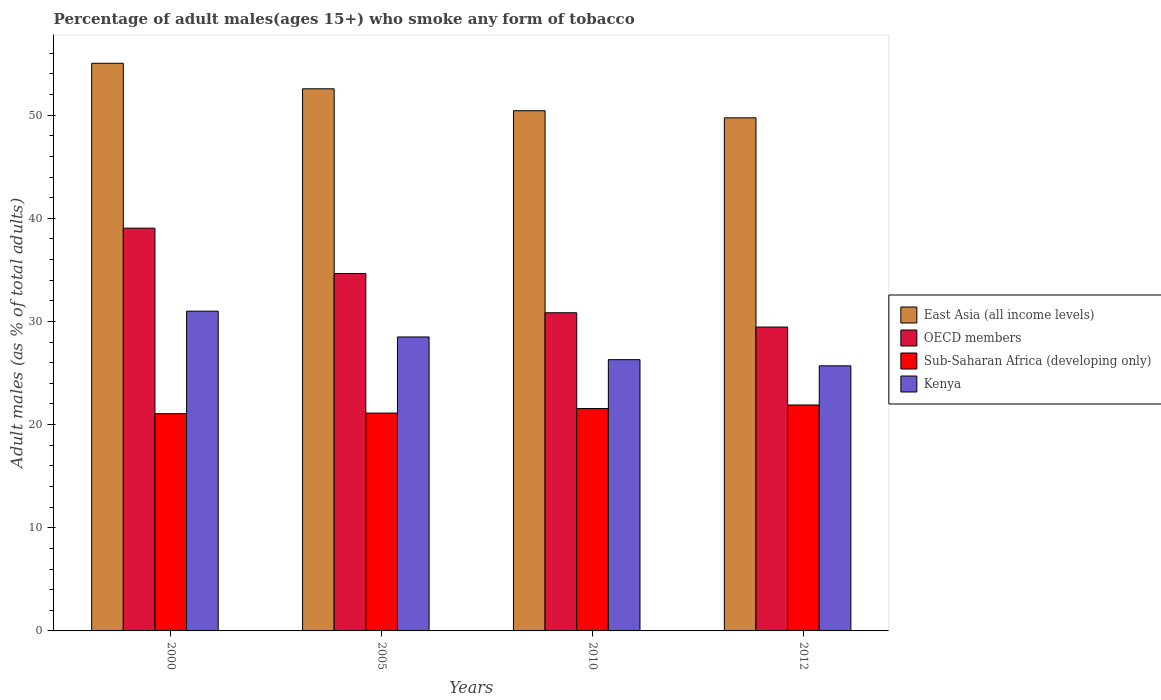How many different coloured bars are there?
Provide a succinct answer. 4. How many groups of bars are there?
Your answer should be very brief. 4. Are the number of bars per tick equal to the number of legend labels?
Your answer should be compact. Yes. How many bars are there on the 2nd tick from the left?
Keep it short and to the point. 4. What is the label of the 2nd group of bars from the left?
Make the answer very short. 2005. In how many cases, is the number of bars for a given year not equal to the number of legend labels?
Offer a terse response. 0. What is the percentage of adult males who smoke in Sub-Saharan Africa (developing only) in 2000?
Give a very brief answer. 21.06. Across all years, what is the maximum percentage of adult males who smoke in Kenya?
Provide a succinct answer. 31. Across all years, what is the minimum percentage of adult males who smoke in Kenya?
Your response must be concise. 25.7. What is the total percentage of adult males who smoke in East Asia (all income levels) in the graph?
Your answer should be compact. 207.77. What is the difference between the percentage of adult males who smoke in East Asia (all income levels) in 2005 and that in 2012?
Keep it short and to the point. 2.81. What is the difference between the percentage of adult males who smoke in Kenya in 2010 and the percentage of adult males who smoke in OECD members in 2012?
Provide a succinct answer. -3.16. What is the average percentage of adult males who smoke in Kenya per year?
Provide a succinct answer. 27.88. In the year 2012, what is the difference between the percentage of adult males who smoke in East Asia (all income levels) and percentage of adult males who smoke in Kenya?
Give a very brief answer. 24.04. In how many years, is the percentage of adult males who smoke in East Asia (all income levels) greater than 24 %?
Your response must be concise. 4. What is the ratio of the percentage of adult males who smoke in Sub-Saharan Africa (developing only) in 2005 to that in 2012?
Provide a succinct answer. 0.96. Is the percentage of adult males who smoke in Sub-Saharan Africa (developing only) in 2000 less than that in 2012?
Your answer should be very brief. Yes. Is the difference between the percentage of adult males who smoke in East Asia (all income levels) in 2010 and 2012 greater than the difference between the percentage of adult males who smoke in Kenya in 2010 and 2012?
Your answer should be compact. Yes. What is the difference between the highest and the second highest percentage of adult males who smoke in Sub-Saharan Africa (developing only)?
Provide a succinct answer. 0.35. What is the difference between the highest and the lowest percentage of adult males who smoke in Kenya?
Offer a very short reply. 5.3. In how many years, is the percentage of adult males who smoke in East Asia (all income levels) greater than the average percentage of adult males who smoke in East Asia (all income levels) taken over all years?
Provide a succinct answer. 2. Is it the case that in every year, the sum of the percentage of adult males who smoke in East Asia (all income levels) and percentage of adult males who smoke in Sub-Saharan Africa (developing only) is greater than the sum of percentage of adult males who smoke in OECD members and percentage of adult males who smoke in Kenya?
Your answer should be compact. Yes. What does the 1st bar from the left in 2005 represents?
Your response must be concise. East Asia (all income levels). What does the 1st bar from the right in 2005 represents?
Your response must be concise. Kenya. Are all the bars in the graph horizontal?
Provide a short and direct response. No. Does the graph contain any zero values?
Your response must be concise. No. Where does the legend appear in the graph?
Your answer should be compact. Center right. What is the title of the graph?
Your answer should be compact. Percentage of adult males(ages 15+) who smoke any form of tobacco. Does "Europe(developing only)" appear as one of the legend labels in the graph?
Your answer should be very brief. No. What is the label or title of the Y-axis?
Offer a very short reply. Adult males (as % of total adults). What is the Adult males (as % of total adults) in East Asia (all income levels) in 2000?
Ensure brevity in your answer.  55.03. What is the Adult males (as % of total adults) of OECD members in 2000?
Provide a succinct answer. 39.05. What is the Adult males (as % of total adults) in Sub-Saharan Africa (developing only) in 2000?
Offer a very short reply. 21.06. What is the Adult males (as % of total adults) of Kenya in 2000?
Provide a succinct answer. 31. What is the Adult males (as % of total adults) of East Asia (all income levels) in 2005?
Offer a very short reply. 52.56. What is the Adult males (as % of total adults) in OECD members in 2005?
Offer a very short reply. 34.65. What is the Adult males (as % of total adults) of Sub-Saharan Africa (developing only) in 2005?
Your answer should be compact. 21.12. What is the Adult males (as % of total adults) in Kenya in 2005?
Provide a short and direct response. 28.5. What is the Adult males (as % of total adults) in East Asia (all income levels) in 2010?
Offer a terse response. 50.43. What is the Adult males (as % of total adults) in OECD members in 2010?
Make the answer very short. 30.85. What is the Adult males (as % of total adults) in Sub-Saharan Africa (developing only) in 2010?
Your answer should be compact. 21.56. What is the Adult males (as % of total adults) in Kenya in 2010?
Offer a terse response. 26.3. What is the Adult males (as % of total adults) in East Asia (all income levels) in 2012?
Offer a very short reply. 49.74. What is the Adult males (as % of total adults) in OECD members in 2012?
Your answer should be compact. 29.46. What is the Adult males (as % of total adults) of Sub-Saharan Africa (developing only) in 2012?
Ensure brevity in your answer.  21.91. What is the Adult males (as % of total adults) of Kenya in 2012?
Provide a succinct answer. 25.7. Across all years, what is the maximum Adult males (as % of total adults) of East Asia (all income levels)?
Provide a succinct answer. 55.03. Across all years, what is the maximum Adult males (as % of total adults) in OECD members?
Offer a terse response. 39.05. Across all years, what is the maximum Adult males (as % of total adults) of Sub-Saharan Africa (developing only)?
Ensure brevity in your answer.  21.91. Across all years, what is the minimum Adult males (as % of total adults) in East Asia (all income levels)?
Provide a succinct answer. 49.74. Across all years, what is the minimum Adult males (as % of total adults) in OECD members?
Offer a very short reply. 29.46. Across all years, what is the minimum Adult males (as % of total adults) in Sub-Saharan Africa (developing only)?
Offer a very short reply. 21.06. Across all years, what is the minimum Adult males (as % of total adults) in Kenya?
Provide a short and direct response. 25.7. What is the total Adult males (as % of total adults) of East Asia (all income levels) in the graph?
Make the answer very short. 207.77. What is the total Adult males (as % of total adults) of OECD members in the graph?
Offer a terse response. 134. What is the total Adult males (as % of total adults) in Sub-Saharan Africa (developing only) in the graph?
Give a very brief answer. 85.64. What is the total Adult males (as % of total adults) in Kenya in the graph?
Make the answer very short. 111.5. What is the difference between the Adult males (as % of total adults) in East Asia (all income levels) in 2000 and that in 2005?
Make the answer very short. 2.48. What is the difference between the Adult males (as % of total adults) in OECD members in 2000 and that in 2005?
Ensure brevity in your answer.  4.4. What is the difference between the Adult males (as % of total adults) in Sub-Saharan Africa (developing only) in 2000 and that in 2005?
Keep it short and to the point. -0.06. What is the difference between the Adult males (as % of total adults) of Kenya in 2000 and that in 2005?
Offer a terse response. 2.5. What is the difference between the Adult males (as % of total adults) of East Asia (all income levels) in 2000 and that in 2010?
Give a very brief answer. 4.6. What is the difference between the Adult males (as % of total adults) in OECD members in 2000 and that in 2010?
Your answer should be compact. 8.2. What is the difference between the Adult males (as % of total adults) of Sub-Saharan Africa (developing only) in 2000 and that in 2010?
Offer a very short reply. -0.5. What is the difference between the Adult males (as % of total adults) of Kenya in 2000 and that in 2010?
Offer a very short reply. 4.7. What is the difference between the Adult males (as % of total adults) of East Asia (all income levels) in 2000 and that in 2012?
Offer a terse response. 5.29. What is the difference between the Adult males (as % of total adults) in OECD members in 2000 and that in 2012?
Your response must be concise. 9.59. What is the difference between the Adult males (as % of total adults) in Sub-Saharan Africa (developing only) in 2000 and that in 2012?
Your answer should be very brief. -0.85. What is the difference between the Adult males (as % of total adults) of East Asia (all income levels) in 2005 and that in 2010?
Your answer should be compact. 2.13. What is the difference between the Adult males (as % of total adults) in OECD members in 2005 and that in 2010?
Provide a short and direct response. 3.81. What is the difference between the Adult males (as % of total adults) of Sub-Saharan Africa (developing only) in 2005 and that in 2010?
Provide a succinct answer. -0.44. What is the difference between the Adult males (as % of total adults) in Kenya in 2005 and that in 2010?
Ensure brevity in your answer.  2.2. What is the difference between the Adult males (as % of total adults) in East Asia (all income levels) in 2005 and that in 2012?
Provide a succinct answer. 2.81. What is the difference between the Adult males (as % of total adults) in OECD members in 2005 and that in 2012?
Your answer should be very brief. 5.19. What is the difference between the Adult males (as % of total adults) in Sub-Saharan Africa (developing only) in 2005 and that in 2012?
Ensure brevity in your answer.  -0.79. What is the difference between the Adult males (as % of total adults) of East Asia (all income levels) in 2010 and that in 2012?
Ensure brevity in your answer.  0.69. What is the difference between the Adult males (as % of total adults) in OECD members in 2010 and that in 2012?
Offer a very short reply. 1.39. What is the difference between the Adult males (as % of total adults) in Sub-Saharan Africa (developing only) in 2010 and that in 2012?
Provide a short and direct response. -0.35. What is the difference between the Adult males (as % of total adults) in Kenya in 2010 and that in 2012?
Make the answer very short. 0.6. What is the difference between the Adult males (as % of total adults) in East Asia (all income levels) in 2000 and the Adult males (as % of total adults) in OECD members in 2005?
Offer a terse response. 20.38. What is the difference between the Adult males (as % of total adults) in East Asia (all income levels) in 2000 and the Adult males (as % of total adults) in Sub-Saharan Africa (developing only) in 2005?
Offer a very short reply. 33.92. What is the difference between the Adult males (as % of total adults) of East Asia (all income levels) in 2000 and the Adult males (as % of total adults) of Kenya in 2005?
Your response must be concise. 26.53. What is the difference between the Adult males (as % of total adults) of OECD members in 2000 and the Adult males (as % of total adults) of Sub-Saharan Africa (developing only) in 2005?
Your response must be concise. 17.93. What is the difference between the Adult males (as % of total adults) of OECD members in 2000 and the Adult males (as % of total adults) of Kenya in 2005?
Provide a succinct answer. 10.55. What is the difference between the Adult males (as % of total adults) of Sub-Saharan Africa (developing only) in 2000 and the Adult males (as % of total adults) of Kenya in 2005?
Offer a terse response. -7.44. What is the difference between the Adult males (as % of total adults) in East Asia (all income levels) in 2000 and the Adult males (as % of total adults) in OECD members in 2010?
Your answer should be compact. 24.19. What is the difference between the Adult males (as % of total adults) in East Asia (all income levels) in 2000 and the Adult males (as % of total adults) in Sub-Saharan Africa (developing only) in 2010?
Your response must be concise. 33.48. What is the difference between the Adult males (as % of total adults) in East Asia (all income levels) in 2000 and the Adult males (as % of total adults) in Kenya in 2010?
Offer a terse response. 28.73. What is the difference between the Adult males (as % of total adults) of OECD members in 2000 and the Adult males (as % of total adults) of Sub-Saharan Africa (developing only) in 2010?
Your answer should be compact. 17.49. What is the difference between the Adult males (as % of total adults) of OECD members in 2000 and the Adult males (as % of total adults) of Kenya in 2010?
Your answer should be very brief. 12.75. What is the difference between the Adult males (as % of total adults) in Sub-Saharan Africa (developing only) in 2000 and the Adult males (as % of total adults) in Kenya in 2010?
Offer a terse response. -5.24. What is the difference between the Adult males (as % of total adults) of East Asia (all income levels) in 2000 and the Adult males (as % of total adults) of OECD members in 2012?
Your answer should be very brief. 25.58. What is the difference between the Adult males (as % of total adults) in East Asia (all income levels) in 2000 and the Adult males (as % of total adults) in Sub-Saharan Africa (developing only) in 2012?
Offer a very short reply. 33.13. What is the difference between the Adult males (as % of total adults) of East Asia (all income levels) in 2000 and the Adult males (as % of total adults) of Kenya in 2012?
Ensure brevity in your answer.  29.33. What is the difference between the Adult males (as % of total adults) in OECD members in 2000 and the Adult males (as % of total adults) in Sub-Saharan Africa (developing only) in 2012?
Keep it short and to the point. 17.14. What is the difference between the Adult males (as % of total adults) of OECD members in 2000 and the Adult males (as % of total adults) of Kenya in 2012?
Provide a short and direct response. 13.35. What is the difference between the Adult males (as % of total adults) in Sub-Saharan Africa (developing only) in 2000 and the Adult males (as % of total adults) in Kenya in 2012?
Your answer should be very brief. -4.64. What is the difference between the Adult males (as % of total adults) of East Asia (all income levels) in 2005 and the Adult males (as % of total adults) of OECD members in 2010?
Your response must be concise. 21.71. What is the difference between the Adult males (as % of total adults) in East Asia (all income levels) in 2005 and the Adult males (as % of total adults) in Sub-Saharan Africa (developing only) in 2010?
Keep it short and to the point. 31. What is the difference between the Adult males (as % of total adults) of East Asia (all income levels) in 2005 and the Adult males (as % of total adults) of Kenya in 2010?
Keep it short and to the point. 26.26. What is the difference between the Adult males (as % of total adults) of OECD members in 2005 and the Adult males (as % of total adults) of Sub-Saharan Africa (developing only) in 2010?
Ensure brevity in your answer.  13.09. What is the difference between the Adult males (as % of total adults) of OECD members in 2005 and the Adult males (as % of total adults) of Kenya in 2010?
Make the answer very short. 8.35. What is the difference between the Adult males (as % of total adults) in Sub-Saharan Africa (developing only) in 2005 and the Adult males (as % of total adults) in Kenya in 2010?
Provide a short and direct response. -5.18. What is the difference between the Adult males (as % of total adults) of East Asia (all income levels) in 2005 and the Adult males (as % of total adults) of OECD members in 2012?
Provide a succinct answer. 23.1. What is the difference between the Adult males (as % of total adults) in East Asia (all income levels) in 2005 and the Adult males (as % of total adults) in Sub-Saharan Africa (developing only) in 2012?
Ensure brevity in your answer.  30.65. What is the difference between the Adult males (as % of total adults) in East Asia (all income levels) in 2005 and the Adult males (as % of total adults) in Kenya in 2012?
Make the answer very short. 26.86. What is the difference between the Adult males (as % of total adults) in OECD members in 2005 and the Adult males (as % of total adults) in Sub-Saharan Africa (developing only) in 2012?
Give a very brief answer. 12.74. What is the difference between the Adult males (as % of total adults) in OECD members in 2005 and the Adult males (as % of total adults) in Kenya in 2012?
Make the answer very short. 8.95. What is the difference between the Adult males (as % of total adults) in Sub-Saharan Africa (developing only) in 2005 and the Adult males (as % of total adults) in Kenya in 2012?
Make the answer very short. -4.58. What is the difference between the Adult males (as % of total adults) in East Asia (all income levels) in 2010 and the Adult males (as % of total adults) in OECD members in 2012?
Make the answer very short. 20.97. What is the difference between the Adult males (as % of total adults) in East Asia (all income levels) in 2010 and the Adult males (as % of total adults) in Sub-Saharan Africa (developing only) in 2012?
Your answer should be compact. 28.53. What is the difference between the Adult males (as % of total adults) in East Asia (all income levels) in 2010 and the Adult males (as % of total adults) in Kenya in 2012?
Your answer should be compact. 24.73. What is the difference between the Adult males (as % of total adults) in OECD members in 2010 and the Adult males (as % of total adults) in Sub-Saharan Africa (developing only) in 2012?
Your response must be concise. 8.94. What is the difference between the Adult males (as % of total adults) in OECD members in 2010 and the Adult males (as % of total adults) in Kenya in 2012?
Offer a very short reply. 5.15. What is the difference between the Adult males (as % of total adults) in Sub-Saharan Africa (developing only) in 2010 and the Adult males (as % of total adults) in Kenya in 2012?
Offer a terse response. -4.14. What is the average Adult males (as % of total adults) in East Asia (all income levels) per year?
Ensure brevity in your answer.  51.94. What is the average Adult males (as % of total adults) of OECD members per year?
Your answer should be very brief. 33.5. What is the average Adult males (as % of total adults) of Sub-Saharan Africa (developing only) per year?
Make the answer very short. 21.41. What is the average Adult males (as % of total adults) in Kenya per year?
Offer a very short reply. 27.88. In the year 2000, what is the difference between the Adult males (as % of total adults) in East Asia (all income levels) and Adult males (as % of total adults) in OECD members?
Offer a very short reply. 15.99. In the year 2000, what is the difference between the Adult males (as % of total adults) in East Asia (all income levels) and Adult males (as % of total adults) in Sub-Saharan Africa (developing only)?
Keep it short and to the point. 33.97. In the year 2000, what is the difference between the Adult males (as % of total adults) of East Asia (all income levels) and Adult males (as % of total adults) of Kenya?
Your answer should be compact. 24.03. In the year 2000, what is the difference between the Adult males (as % of total adults) of OECD members and Adult males (as % of total adults) of Sub-Saharan Africa (developing only)?
Offer a terse response. 17.99. In the year 2000, what is the difference between the Adult males (as % of total adults) of OECD members and Adult males (as % of total adults) of Kenya?
Provide a succinct answer. 8.05. In the year 2000, what is the difference between the Adult males (as % of total adults) in Sub-Saharan Africa (developing only) and Adult males (as % of total adults) in Kenya?
Provide a succinct answer. -9.94. In the year 2005, what is the difference between the Adult males (as % of total adults) in East Asia (all income levels) and Adult males (as % of total adults) in OECD members?
Offer a very short reply. 17.91. In the year 2005, what is the difference between the Adult males (as % of total adults) of East Asia (all income levels) and Adult males (as % of total adults) of Sub-Saharan Africa (developing only)?
Offer a very short reply. 31.44. In the year 2005, what is the difference between the Adult males (as % of total adults) in East Asia (all income levels) and Adult males (as % of total adults) in Kenya?
Make the answer very short. 24.06. In the year 2005, what is the difference between the Adult males (as % of total adults) of OECD members and Adult males (as % of total adults) of Sub-Saharan Africa (developing only)?
Your response must be concise. 13.53. In the year 2005, what is the difference between the Adult males (as % of total adults) in OECD members and Adult males (as % of total adults) in Kenya?
Provide a short and direct response. 6.15. In the year 2005, what is the difference between the Adult males (as % of total adults) in Sub-Saharan Africa (developing only) and Adult males (as % of total adults) in Kenya?
Make the answer very short. -7.38. In the year 2010, what is the difference between the Adult males (as % of total adults) in East Asia (all income levels) and Adult males (as % of total adults) in OECD members?
Your response must be concise. 19.59. In the year 2010, what is the difference between the Adult males (as % of total adults) in East Asia (all income levels) and Adult males (as % of total adults) in Sub-Saharan Africa (developing only)?
Your response must be concise. 28.87. In the year 2010, what is the difference between the Adult males (as % of total adults) of East Asia (all income levels) and Adult males (as % of total adults) of Kenya?
Your response must be concise. 24.13. In the year 2010, what is the difference between the Adult males (as % of total adults) of OECD members and Adult males (as % of total adults) of Sub-Saharan Africa (developing only)?
Provide a short and direct response. 9.29. In the year 2010, what is the difference between the Adult males (as % of total adults) in OECD members and Adult males (as % of total adults) in Kenya?
Provide a succinct answer. 4.55. In the year 2010, what is the difference between the Adult males (as % of total adults) in Sub-Saharan Africa (developing only) and Adult males (as % of total adults) in Kenya?
Give a very brief answer. -4.74. In the year 2012, what is the difference between the Adult males (as % of total adults) in East Asia (all income levels) and Adult males (as % of total adults) in OECD members?
Keep it short and to the point. 20.28. In the year 2012, what is the difference between the Adult males (as % of total adults) of East Asia (all income levels) and Adult males (as % of total adults) of Sub-Saharan Africa (developing only)?
Provide a short and direct response. 27.84. In the year 2012, what is the difference between the Adult males (as % of total adults) of East Asia (all income levels) and Adult males (as % of total adults) of Kenya?
Your response must be concise. 24.04. In the year 2012, what is the difference between the Adult males (as % of total adults) in OECD members and Adult males (as % of total adults) in Sub-Saharan Africa (developing only)?
Your response must be concise. 7.55. In the year 2012, what is the difference between the Adult males (as % of total adults) of OECD members and Adult males (as % of total adults) of Kenya?
Offer a terse response. 3.76. In the year 2012, what is the difference between the Adult males (as % of total adults) in Sub-Saharan Africa (developing only) and Adult males (as % of total adults) in Kenya?
Ensure brevity in your answer.  -3.79. What is the ratio of the Adult males (as % of total adults) of East Asia (all income levels) in 2000 to that in 2005?
Give a very brief answer. 1.05. What is the ratio of the Adult males (as % of total adults) of OECD members in 2000 to that in 2005?
Make the answer very short. 1.13. What is the ratio of the Adult males (as % of total adults) of Sub-Saharan Africa (developing only) in 2000 to that in 2005?
Offer a very short reply. 1. What is the ratio of the Adult males (as % of total adults) of Kenya in 2000 to that in 2005?
Your answer should be compact. 1.09. What is the ratio of the Adult males (as % of total adults) of East Asia (all income levels) in 2000 to that in 2010?
Make the answer very short. 1.09. What is the ratio of the Adult males (as % of total adults) in OECD members in 2000 to that in 2010?
Offer a very short reply. 1.27. What is the ratio of the Adult males (as % of total adults) in Sub-Saharan Africa (developing only) in 2000 to that in 2010?
Offer a terse response. 0.98. What is the ratio of the Adult males (as % of total adults) of Kenya in 2000 to that in 2010?
Keep it short and to the point. 1.18. What is the ratio of the Adult males (as % of total adults) of East Asia (all income levels) in 2000 to that in 2012?
Your response must be concise. 1.11. What is the ratio of the Adult males (as % of total adults) in OECD members in 2000 to that in 2012?
Provide a succinct answer. 1.33. What is the ratio of the Adult males (as % of total adults) of Sub-Saharan Africa (developing only) in 2000 to that in 2012?
Offer a very short reply. 0.96. What is the ratio of the Adult males (as % of total adults) of Kenya in 2000 to that in 2012?
Provide a succinct answer. 1.21. What is the ratio of the Adult males (as % of total adults) in East Asia (all income levels) in 2005 to that in 2010?
Offer a very short reply. 1.04. What is the ratio of the Adult males (as % of total adults) in OECD members in 2005 to that in 2010?
Give a very brief answer. 1.12. What is the ratio of the Adult males (as % of total adults) of Sub-Saharan Africa (developing only) in 2005 to that in 2010?
Keep it short and to the point. 0.98. What is the ratio of the Adult males (as % of total adults) in Kenya in 2005 to that in 2010?
Give a very brief answer. 1.08. What is the ratio of the Adult males (as % of total adults) of East Asia (all income levels) in 2005 to that in 2012?
Your answer should be compact. 1.06. What is the ratio of the Adult males (as % of total adults) in OECD members in 2005 to that in 2012?
Your answer should be compact. 1.18. What is the ratio of the Adult males (as % of total adults) in Sub-Saharan Africa (developing only) in 2005 to that in 2012?
Give a very brief answer. 0.96. What is the ratio of the Adult males (as % of total adults) of Kenya in 2005 to that in 2012?
Give a very brief answer. 1.11. What is the ratio of the Adult males (as % of total adults) in East Asia (all income levels) in 2010 to that in 2012?
Offer a very short reply. 1.01. What is the ratio of the Adult males (as % of total adults) of OECD members in 2010 to that in 2012?
Your response must be concise. 1.05. What is the ratio of the Adult males (as % of total adults) in Sub-Saharan Africa (developing only) in 2010 to that in 2012?
Your answer should be compact. 0.98. What is the ratio of the Adult males (as % of total adults) in Kenya in 2010 to that in 2012?
Ensure brevity in your answer.  1.02. What is the difference between the highest and the second highest Adult males (as % of total adults) of East Asia (all income levels)?
Your answer should be very brief. 2.48. What is the difference between the highest and the second highest Adult males (as % of total adults) in OECD members?
Your answer should be very brief. 4.4. What is the difference between the highest and the second highest Adult males (as % of total adults) in Sub-Saharan Africa (developing only)?
Ensure brevity in your answer.  0.35. What is the difference between the highest and the lowest Adult males (as % of total adults) of East Asia (all income levels)?
Your answer should be compact. 5.29. What is the difference between the highest and the lowest Adult males (as % of total adults) in OECD members?
Ensure brevity in your answer.  9.59. What is the difference between the highest and the lowest Adult males (as % of total adults) in Sub-Saharan Africa (developing only)?
Ensure brevity in your answer.  0.85. What is the difference between the highest and the lowest Adult males (as % of total adults) in Kenya?
Make the answer very short. 5.3. 